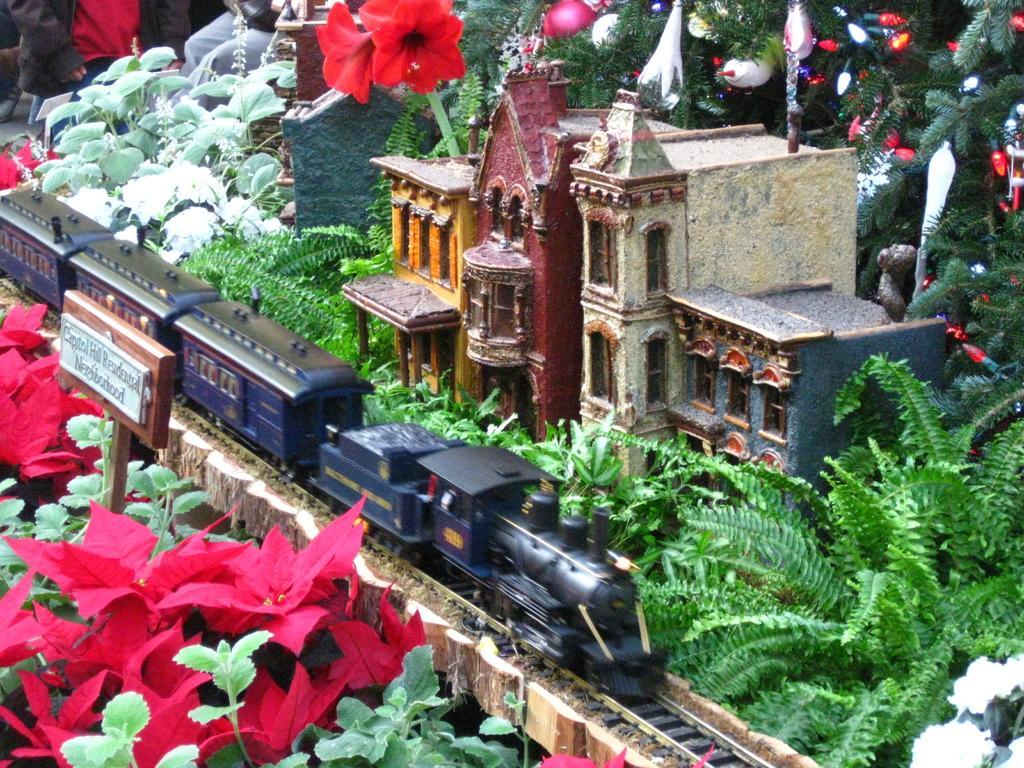Can you describe this image briefly? Here I can see a toy building. In front of this there is a toy train. Around there are many plants along with the flowers. At the back of this toy building there is a Christmas tree. In the top left-hand corner, I can see few people. 